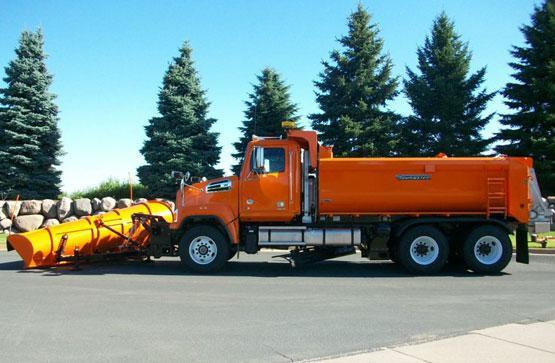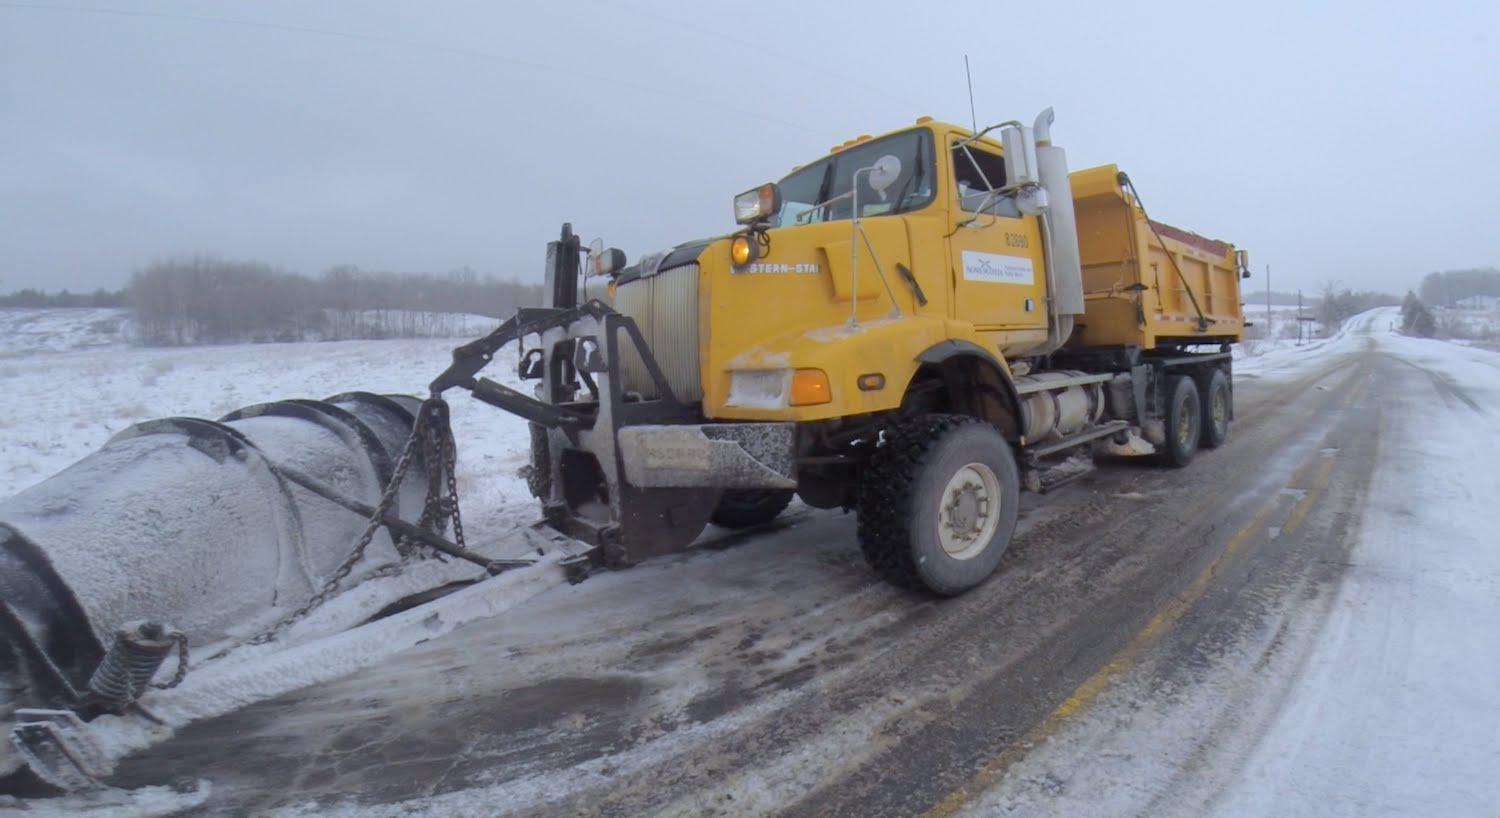The first image is the image on the left, the second image is the image on the right. Assess this claim about the two images: "There is a snowplow plowing snow.". Correct or not? Answer yes or no. Yes. 